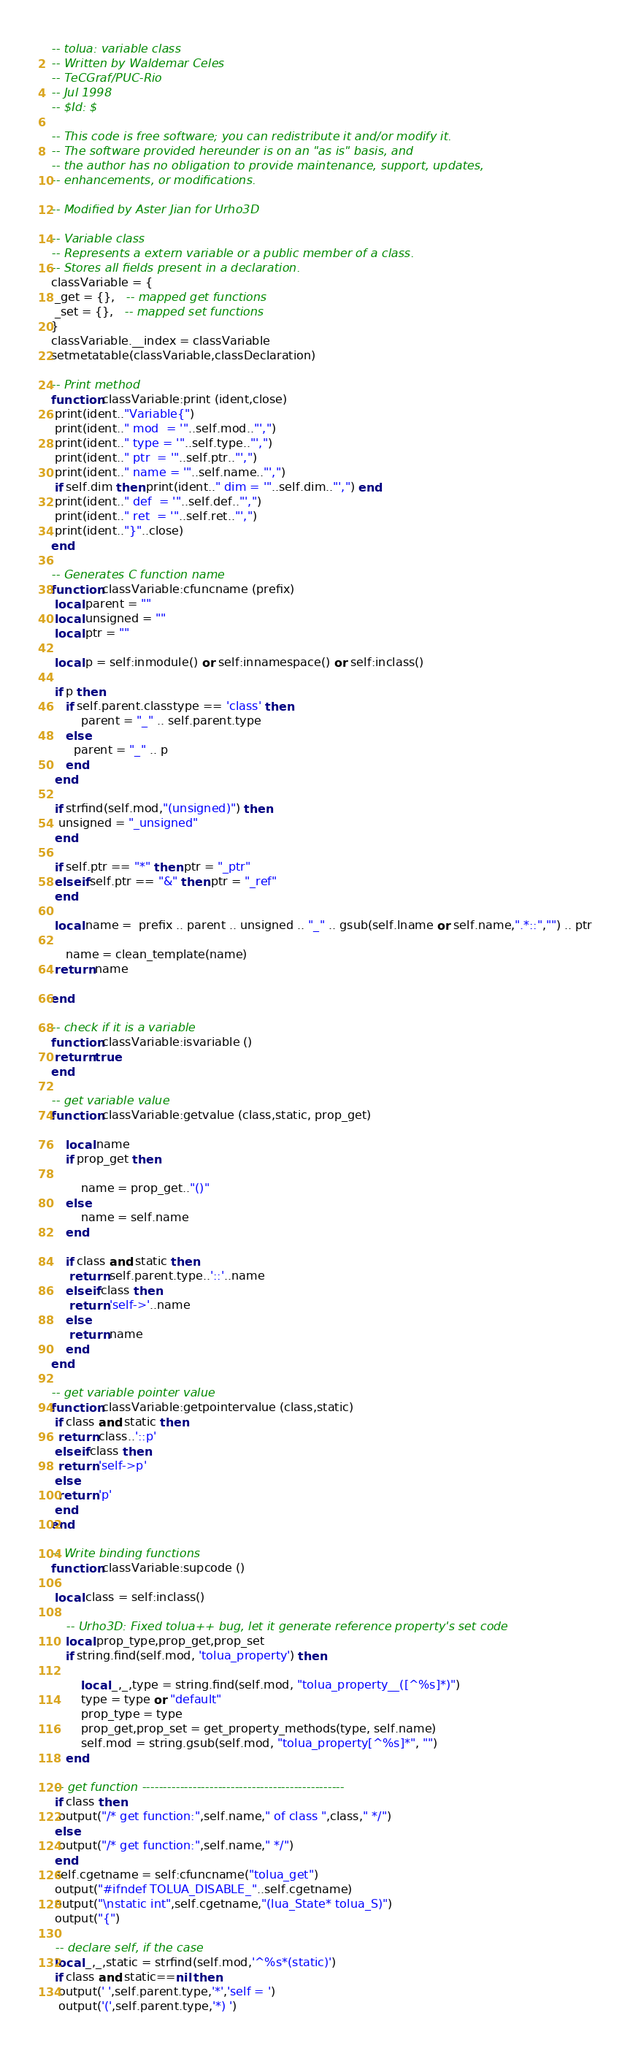<code> <loc_0><loc_0><loc_500><loc_500><_Lua_>-- tolua: variable class
-- Written by Waldemar Celes
-- TeCGraf/PUC-Rio
-- Jul 1998
-- $Id: $

-- This code is free software; you can redistribute it and/or modify it.
-- The software provided hereunder is on an "as is" basis, and
-- the author has no obligation to provide maintenance, support, updates,
-- enhancements, or modifications.

-- Modified by Aster Jian for Urho3D

-- Variable class
-- Represents a extern variable or a public member of a class.
-- Stores all fields present in a declaration.
classVariable = {
 _get = {},   -- mapped get functions
 _set = {},   -- mapped set functions
}
classVariable.__index = classVariable
setmetatable(classVariable,classDeclaration)

-- Print method
function classVariable:print (ident,close)
 print(ident.."Variable{")
 print(ident.." mod  = '"..self.mod.."',")
 print(ident.." type = '"..self.type.."',")
 print(ident.." ptr  = '"..self.ptr.."',")
 print(ident.." name = '"..self.name.."',")
 if self.dim then print(ident.." dim = '"..self.dim.."',") end
 print(ident.." def  = '"..self.def.."',")
 print(ident.." ret  = '"..self.ret.."',")
 print(ident.."}"..close)
end

-- Generates C function name
function classVariable:cfuncname (prefix)
 local parent = ""
 local unsigned = ""
 local ptr = ""

 local p = self:inmodule() or self:innamespace() or self:inclass()

 if p then
 	if self.parent.classtype == 'class' then
		parent = "_" .. self.parent.type
	else
	  parent = "_" .. p
	end
 end

 if strfind(self.mod,"(unsigned)") then
  unsigned = "_unsigned"
 end

 if self.ptr == "*" then ptr = "_ptr"
 elseif self.ptr == "&" then ptr = "_ref"
 end

 local name =  prefix .. parent .. unsigned .. "_" .. gsub(self.lname or self.name,".*::","") .. ptr

	name = clean_template(name)
 return name

end

-- check if it is a variable
function classVariable:isvariable ()
 return true
end

-- get variable value
function classVariable:getvalue (class,static, prop_get)

	local name
	if prop_get then

		name = prop_get.."()"
	else
		name = self.name
	end

	if class and static then
	 return self.parent.type..'::'..name
	elseif class then
	 return 'self->'..name
	else
	 return name
	end
end

-- get variable pointer value
function classVariable:getpointervalue (class,static)
 if class and static then
  return class..'::p'
 elseif class then
  return 'self->p'
 else
  return 'p'
 end
end

-- Write binding functions
function classVariable:supcode ()

 local class = self:inclass()

    -- Urho3D: Fixed tolua++ bug, let it generate reference property's set code
	local prop_type,prop_get,prop_set
	if string.find(self.mod, 'tolua_property') then

		local _,_,type = string.find(self.mod, "tolua_property__([^%s]*)")
		type = type or "default"
		prop_type = type
		prop_get,prop_set = get_property_methods(type, self.name)
		self.mod = string.gsub(self.mod, "tolua_property[^%s]*", "")
	end

 -- get function ------------------------------------------------
 if class then
  output("/* get function:",self.name," of class ",class," */")
 else
  output("/* get function:",self.name," */")
 end
 self.cgetname = self:cfuncname("tolua_get")
 output("#ifndef TOLUA_DISABLE_"..self.cgetname)
 output("\nstatic int",self.cgetname,"(lua_State* tolua_S)")
 output("{")

 -- declare self, if the case
 local _,_,static = strfind(self.mod,'^%s*(static)')
 if class and static==nil then
  output(' ',self.parent.type,'*','self = ')
  output('(',self.parent.type,'*) ')</code> 